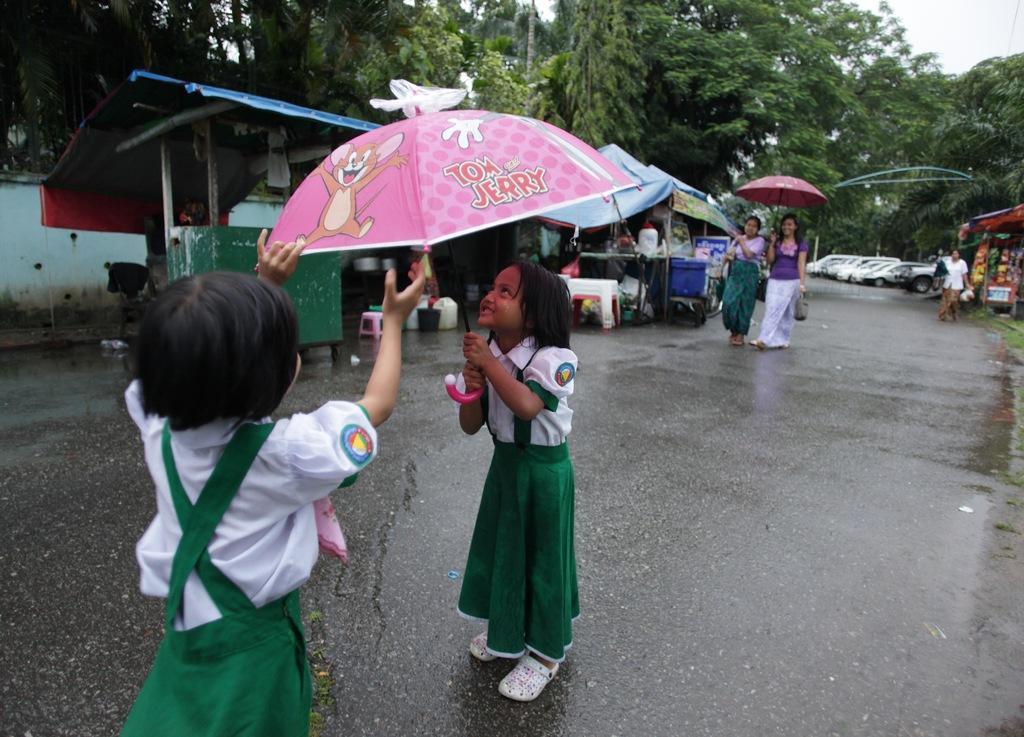Describe this image in one or two sentences. In this image, we can see kids wearing uniform and one of them is holding an umbrella and in the background, there are some other people and one of them is holding a bag and an umbrella and we can see trees, sheds, some packets, boxes, tents and some other objects and there are vehicles on the road. 